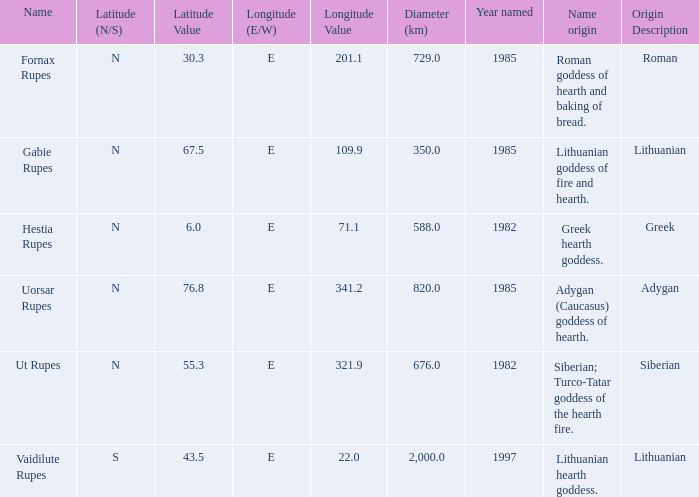What is the latitudinal coordinate of vaidilute rupes? 43.5S. 